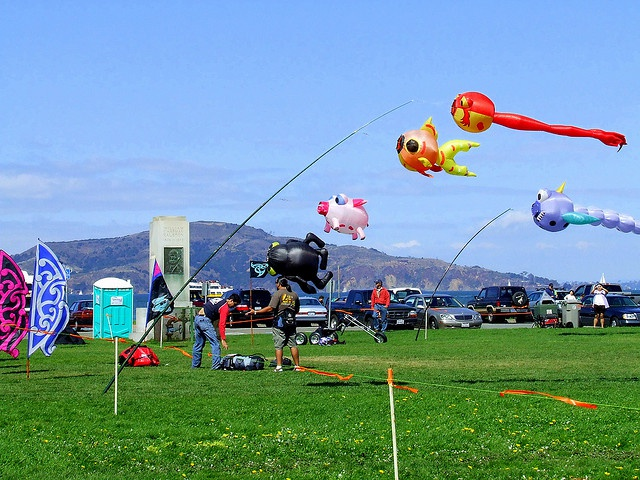Describe the objects in this image and their specific colors. I can see kite in lightblue, red, brown, and salmon tones, kite in lightblue, khaki, olive, brown, and red tones, kite in lightblue, lavender, and blue tones, kite in lightblue, black, gray, and darkgray tones, and car in lightblue, black, gray, and navy tones in this image. 